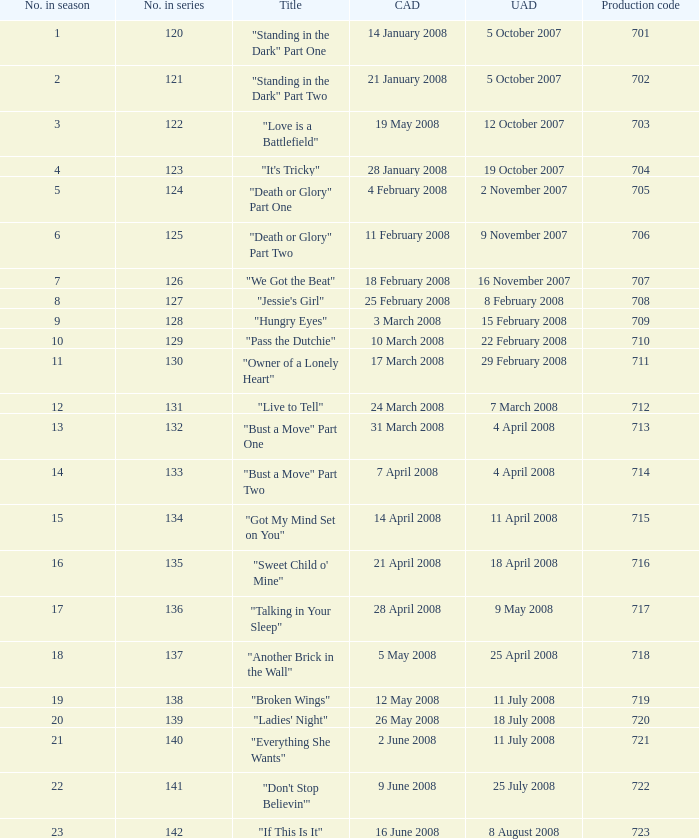For the episode(s) aired in the U.S. on 4 april 2008, what were the names? "Bust a Move" Part One, "Bust a Move" Part Two. 